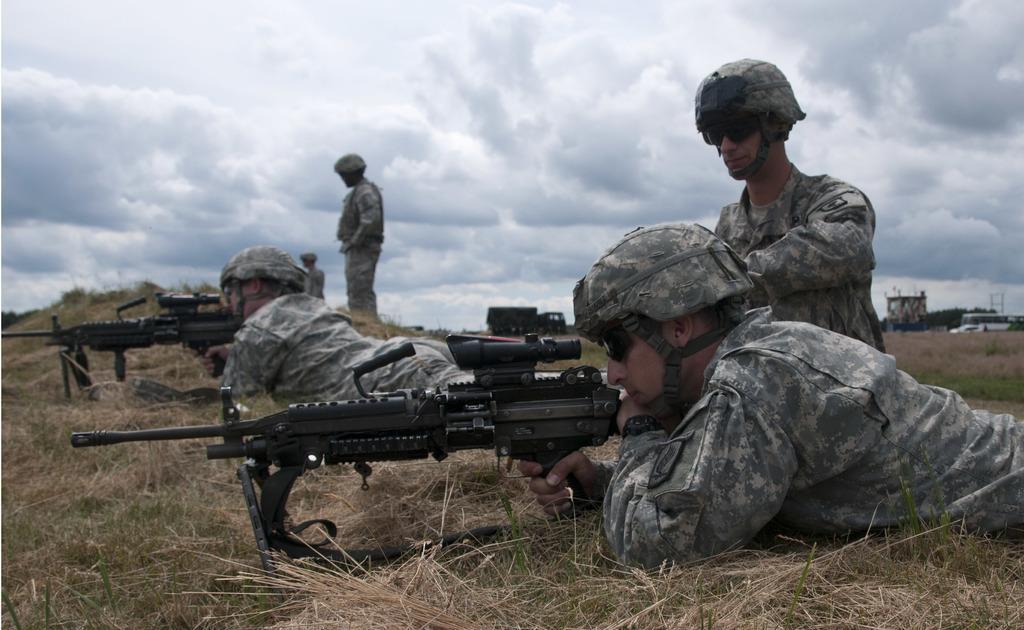Please provide a concise description of this image. The picture consists of soldiers, guns, grass and dry grass. In the background there are buildings and vehicles. Sky is cloudy. 